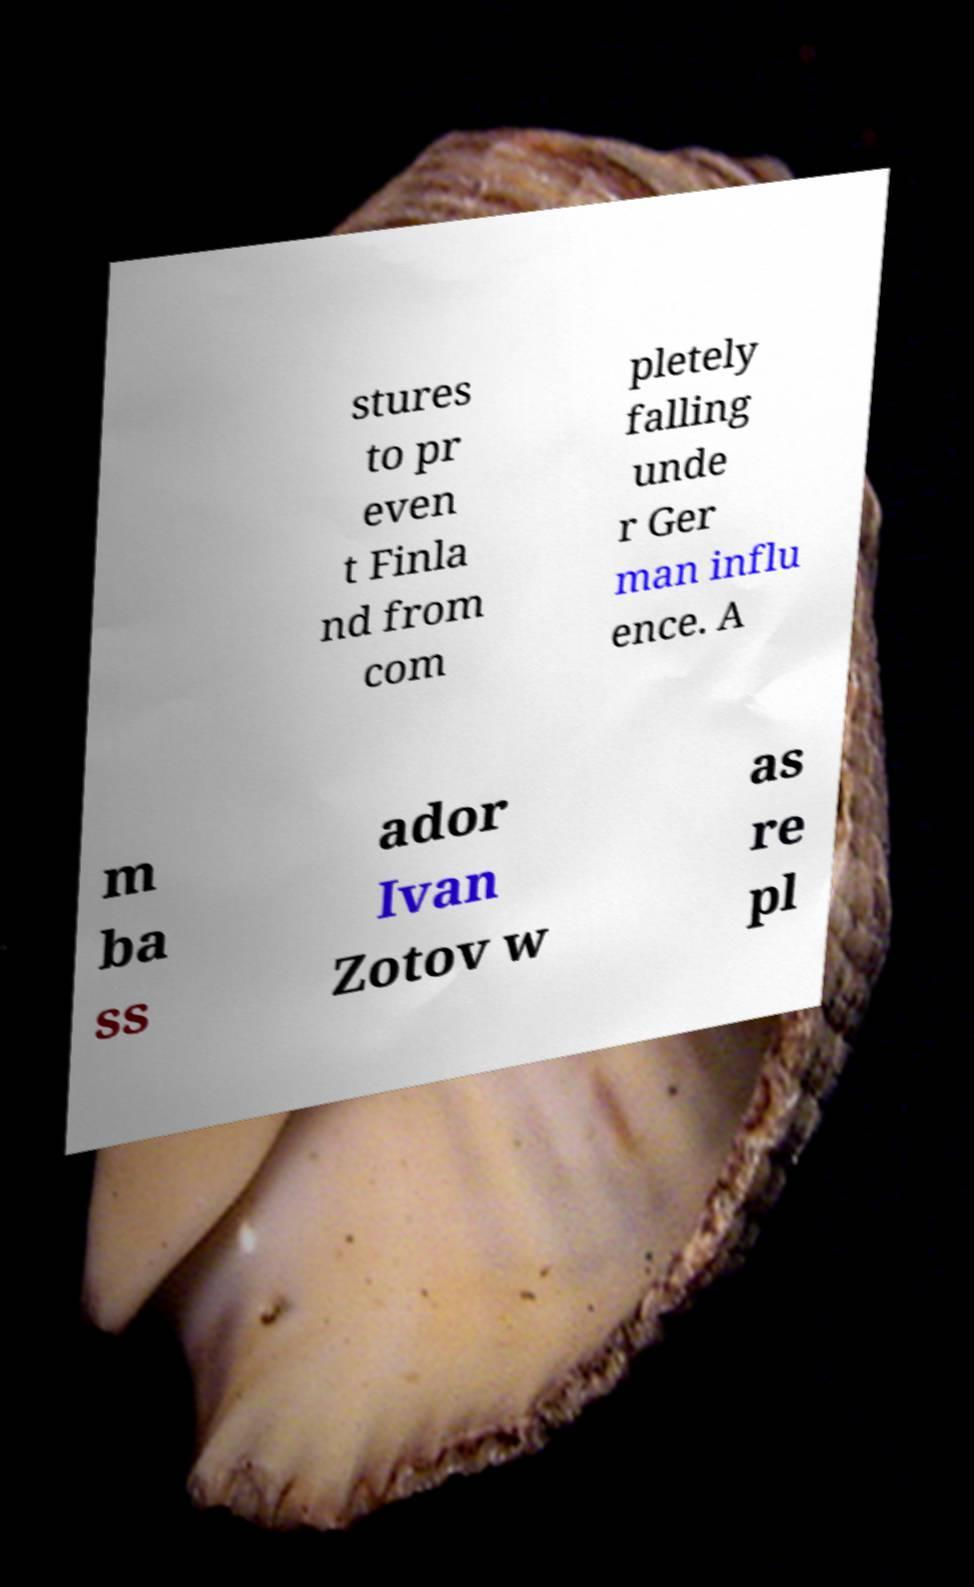There's text embedded in this image that I need extracted. Can you transcribe it verbatim? stures to pr even t Finla nd from com pletely falling unde r Ger man influ ence. A m ba ss ador Ivan Zotov w as re pl 